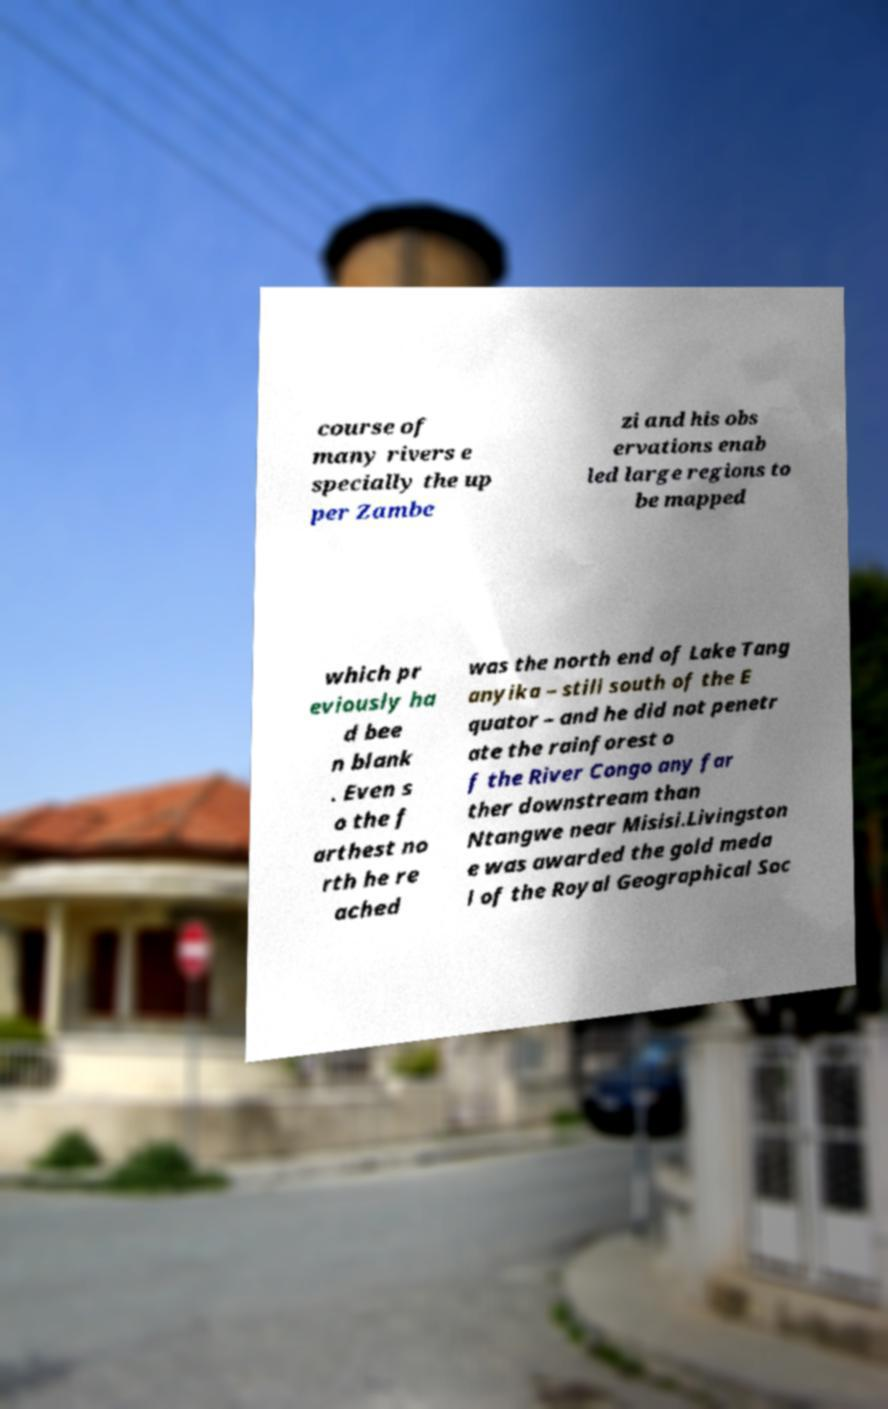For documentation purposes, I need the text within this image transcribed. Could you provide that? course of many rivers e specially the up per Zambe zi and his obs ervations enab led large regions to be mapped which pr eviously ha d bee n blank . Even s o the f arthest no rth he re ached was the north end of Lake Tang anyika – still south of the E quator – and he did not penetr ate the rainforest o f the River Congo any far ther downstream than Ntangwe near Misisi.Livingston e was awarded the gold meda l of the Royal Geographical Soc 